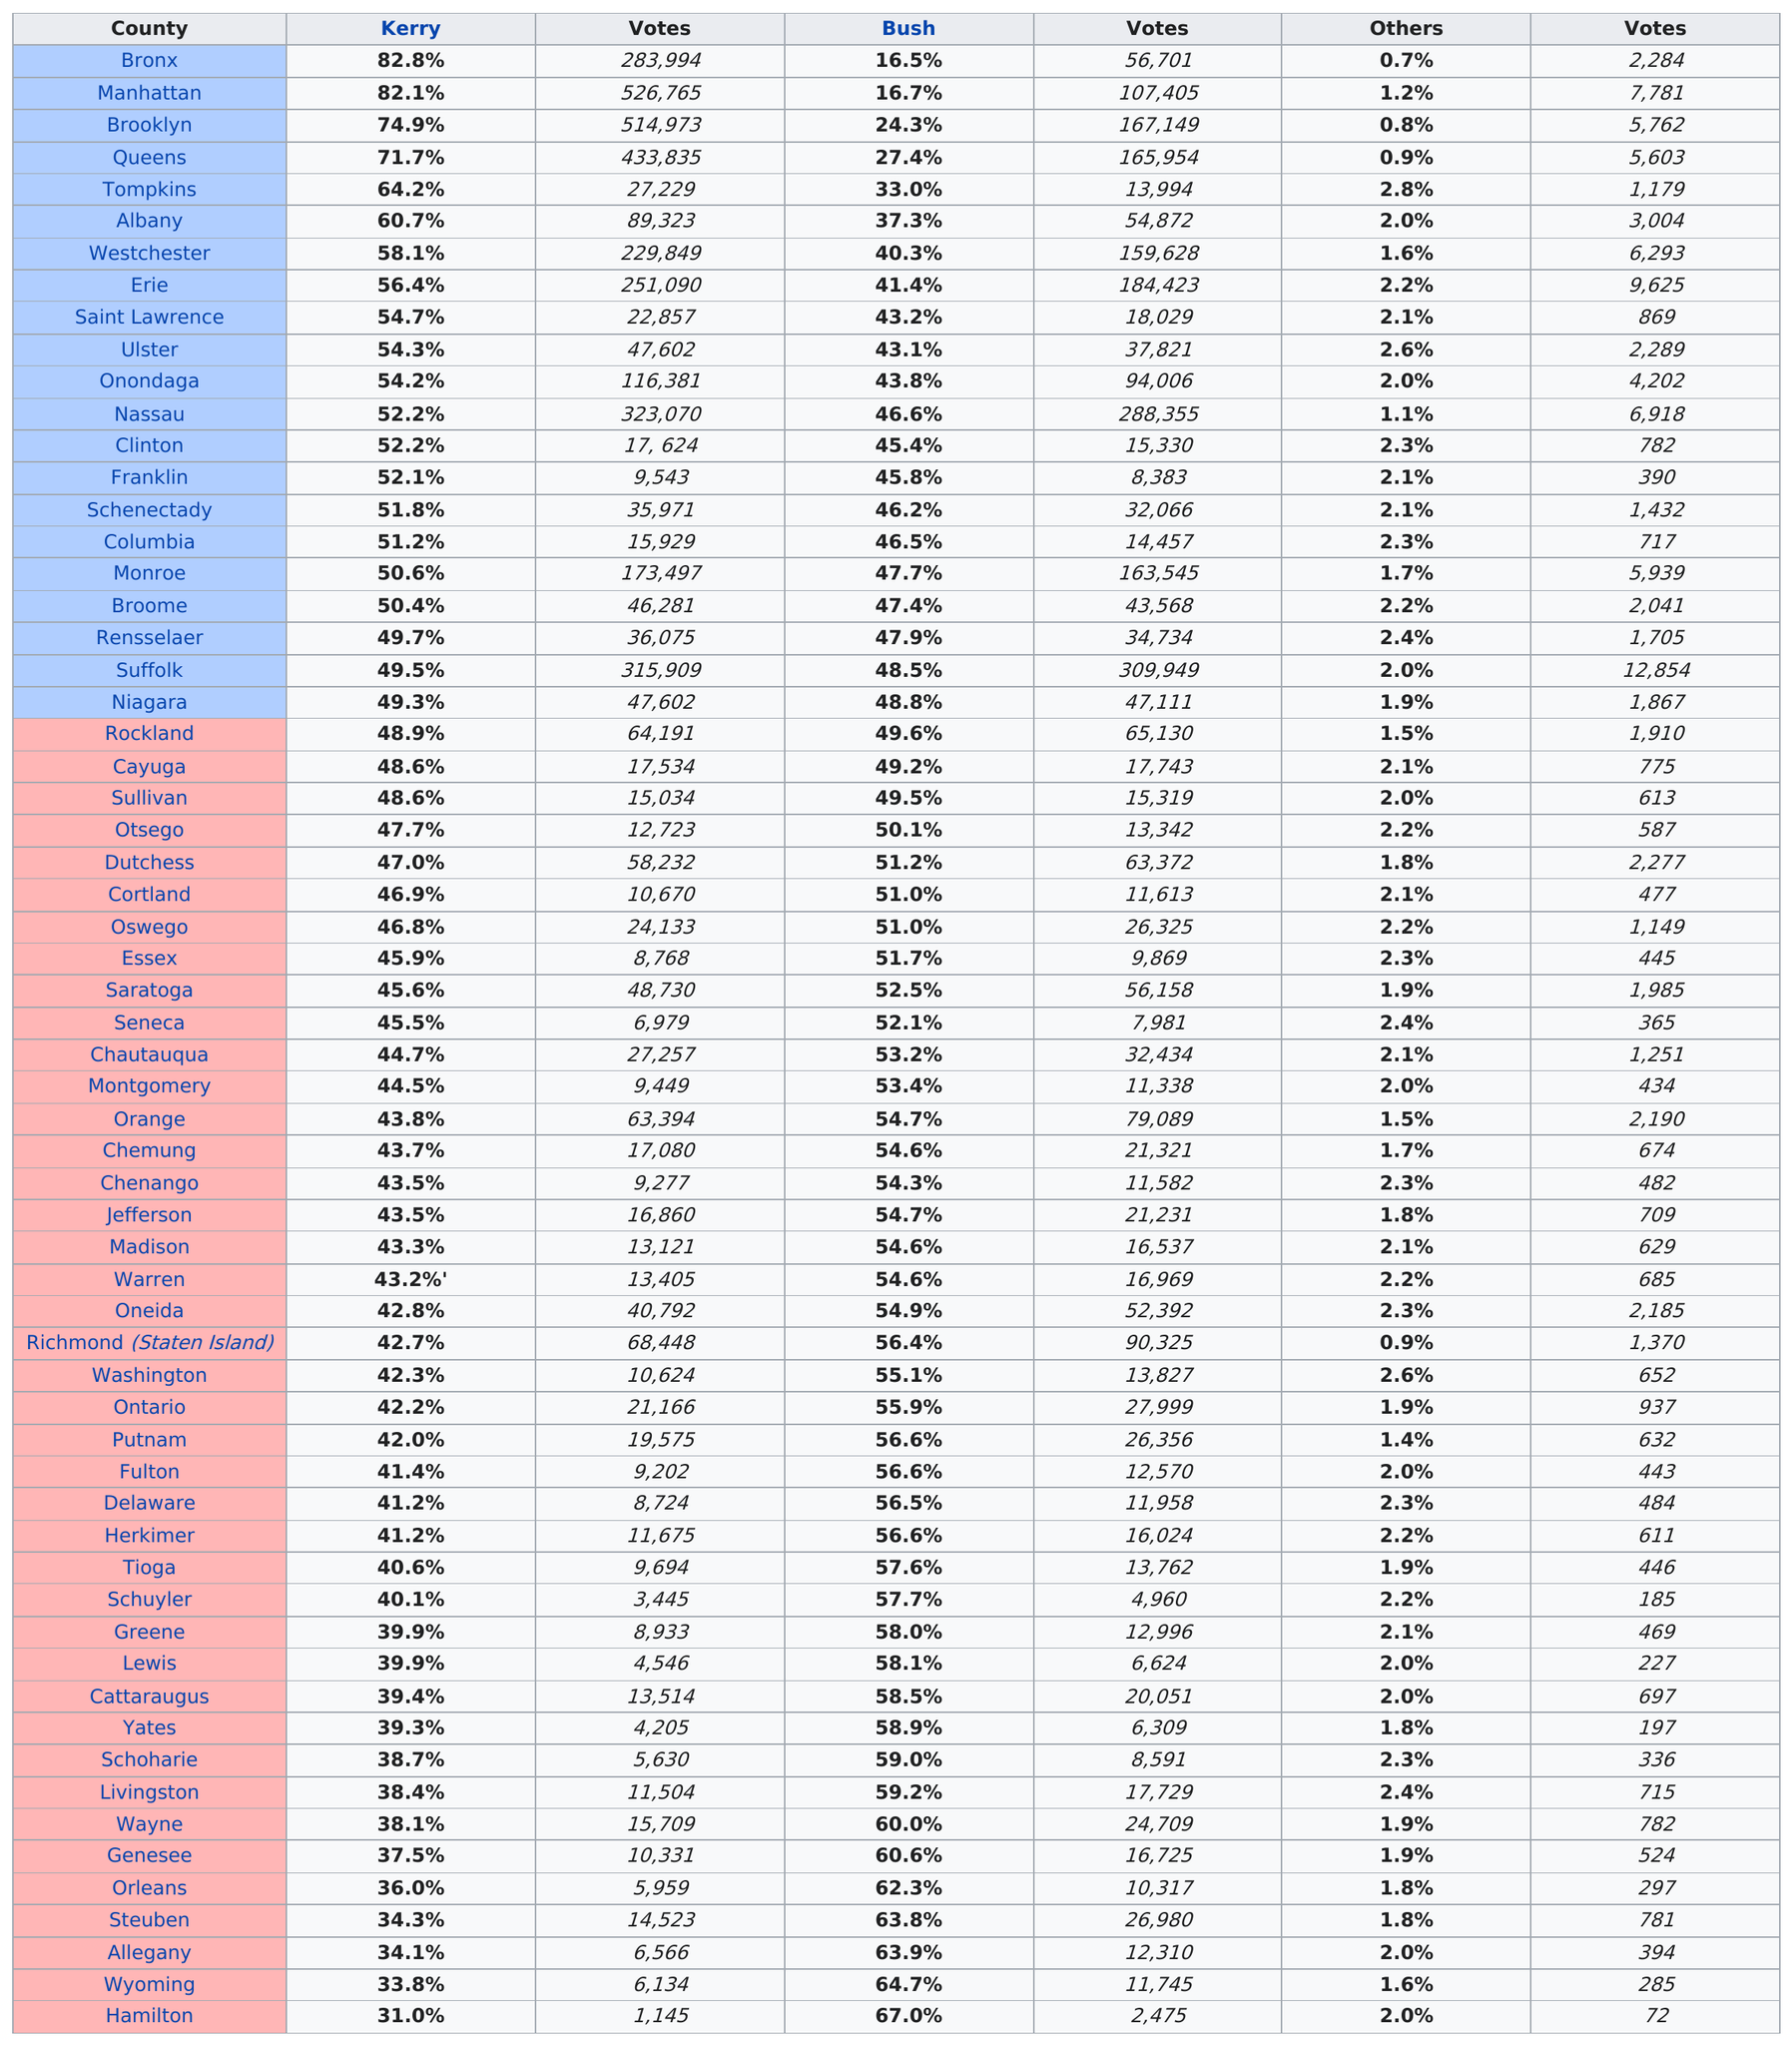Highlight a few significant elements in this photo. Kerry won the most votes in the county of Bronx in New York. In Rockland County, Bush won the election, according to the information provided. The difference in votes between Orange County and Los Angeles County is 15,695. In New York, John Kerry won at least 50% of the popular vote in 18 counties. In Tompkins County, the candidate for President attracted the most votes from voters who did not support George W. Bush or John Kerry. 